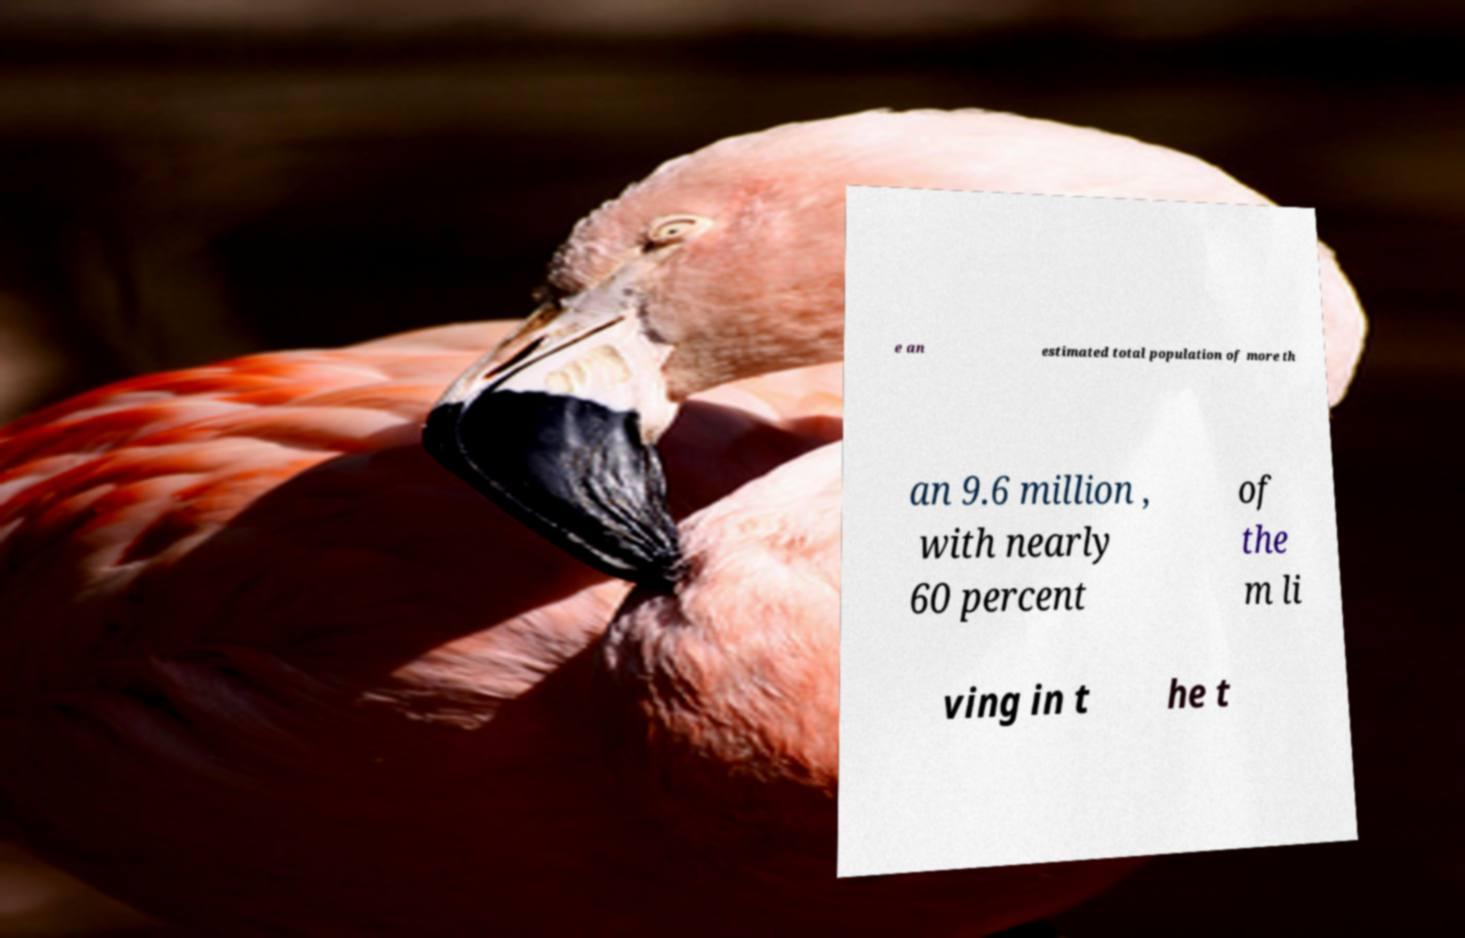I need the written content from this picture converted into text. Can you do that? e an estimated total population of more th an 9.6 million , with nearly 60 percent of the m li ving in t he t 